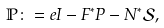Convert formula to latex. <formula><loc_0><loc_0><loc_500><loc_500>\mathbb { P } \colon = e I - F ^ { \ast } P - N ^ { \ast } \mathcal { S } ,</formula> 